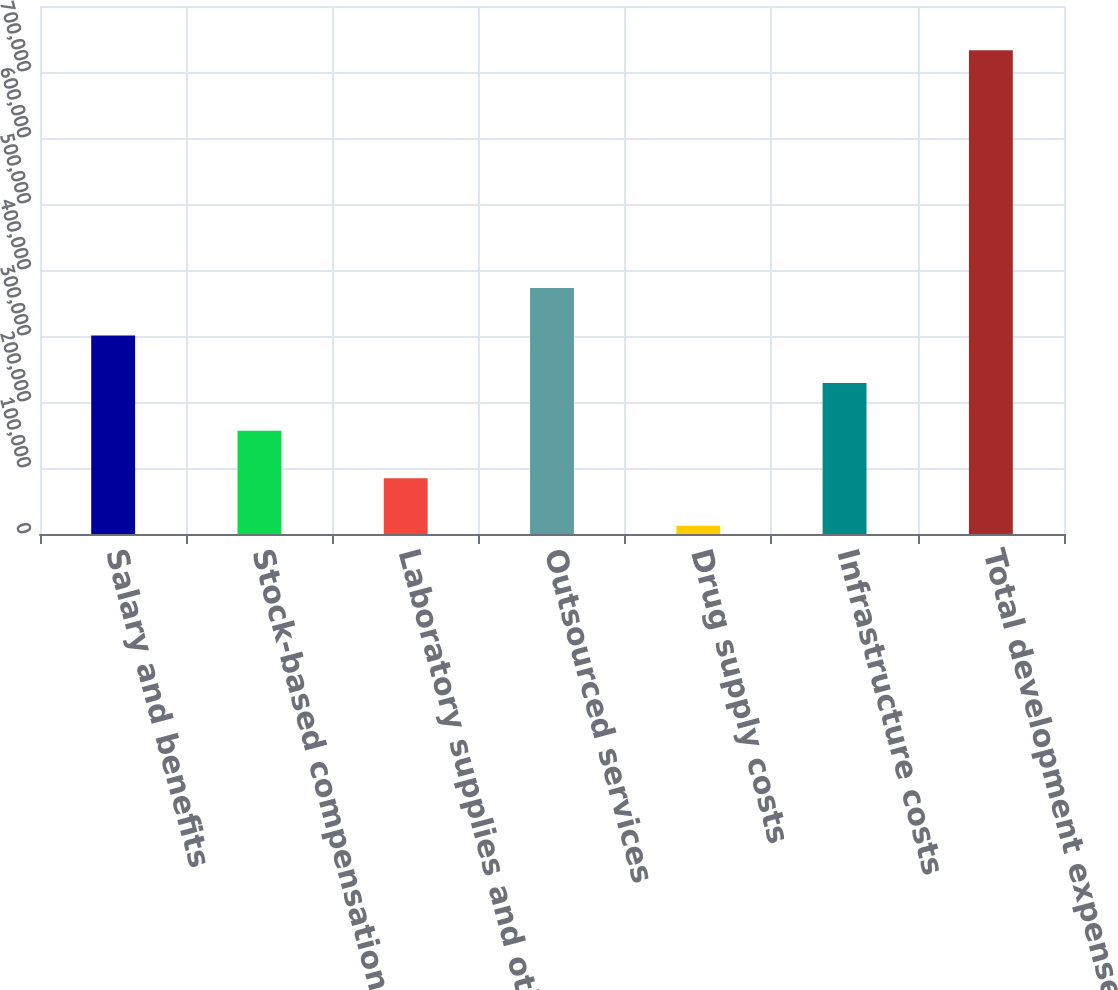Convert chart to OTSL. <chart><loc_0><loc_0><loc_500><loc_500><bar_chart><fcel>Salary and benefits<fcel>Stock-based compensation<fcel>Laboratory supplies and other<fcel>Outsourced services<fcel>Drug supply costs<fcel>Infrastructure costs<fcel>Total development expenses<nl><fcel>300741<fcel>156626<fcel>84567.8<fcel>372799<fcel>12510<fcel>228683<fcel>733088<nl></chart> 